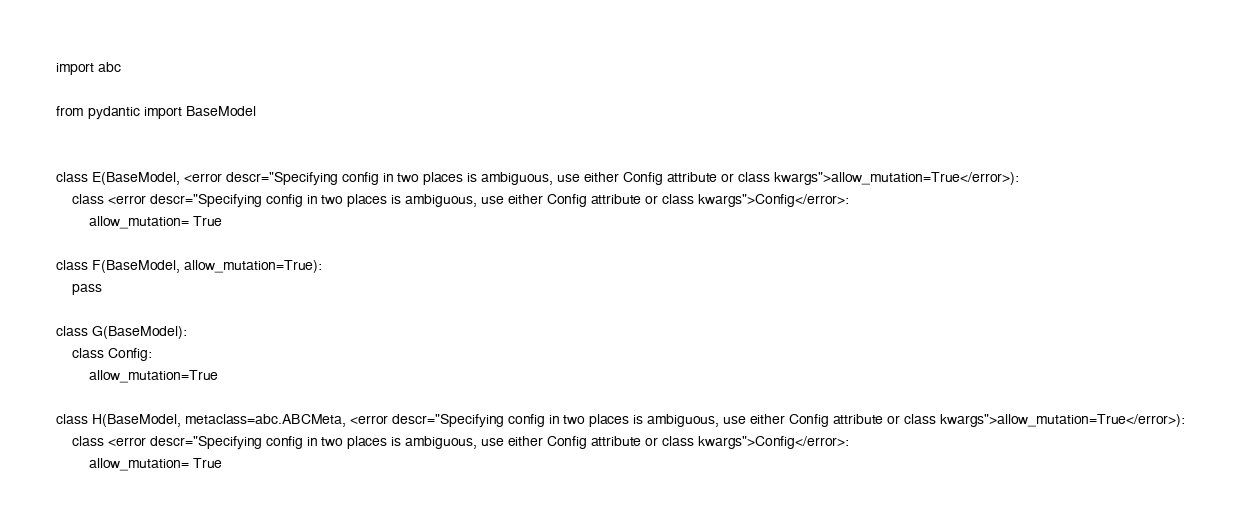<code> <loc_0><loc_0><loc_500><loc_500><_Python_>import abc

from pydantic import BaseModel


class E(BaseModel, <error descr="Specifying config in two places is ambiguous, use either Config attribute or class kwargs">allow_mutation=True</error>):
    class <error descr="Specifying config in two places is ambiguous, use either Config attribute or class kwargs">Config</error>:
        allow_mutation= True

class F(BaseModel, allow_mutation=True):
    pass

class G(BaseModel):
    class Config:
        allow_mutation=True

class H(BaseModel, metaclass=abc.ABCMeta, <error descr="Specifying config in two places is ambiguous, use either Config attribute or class kwargs">allow_mutation=True</error>):
    class <error descr="Specifying config in two places is ambiguous, use either Config attribute or class kwargs">Config</error>:
        allow_mutation= True
</code> 